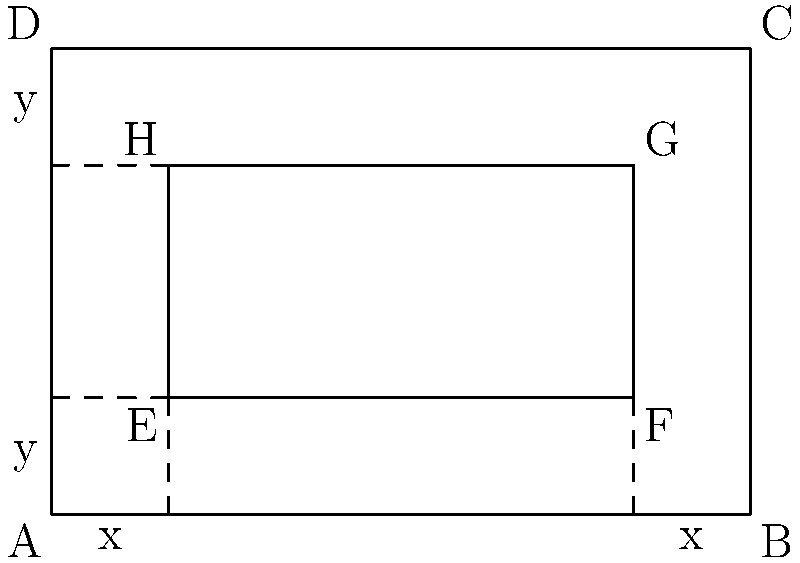A Masonic temple's floor plan is represented by a rectangle ABCD with dimensions 6 meters by 4 meters. An inner rectangular area EFGH is to be designated for ceremonial purposes, with x meters between the sides of EFGH and the longer sides of ABCD, and y meters between the sides of EFGH and the shorter sides of ABCD. If the area of EFGH needs to be maximized, find the optimal values of x and y. Let's approach this step-by-step:

1) The area of EFGH can be expressed as a function of x and y:
   Area = (6 - 2x)(4 - 2y)

2) Expanding this expression:
   Area = 24 - 12x - 12y + 4xy

3) To find the maximum, we need to find the partial derivatives with respect to x and y and set them to zero:

   $$\frac{\partial A}{\partial x} = -12 + 4y = 0$$
   $$\frac{\partial A}{\partial y} = -12 + 4x = 0$$

4) From these equations:
   4y = 12, so y = 3
   4x = 12, so x = 3

5) To confirm this is a maximum, we can check the second derivatives:

   $$\frac{\partial^2 A}{\partial x^2} = 0$$
   $$\frac{\partial^2 A}{\partial y^2} = 0$$
   $$\frac{\partial^2 A}{\partial x \partial y} = 4$$

   The determinant of the Hessian matrix is negative, confirming a maximum.

6) Therefore, the optimal values are x = 1 and y = 1.

7) We can verify: 
   With x = 1 and y = 1, EFGH has dimensions 4m by 2m, which indeed maximizes the area at 8 square meters.
Answer: x = 1m, y = 1m 